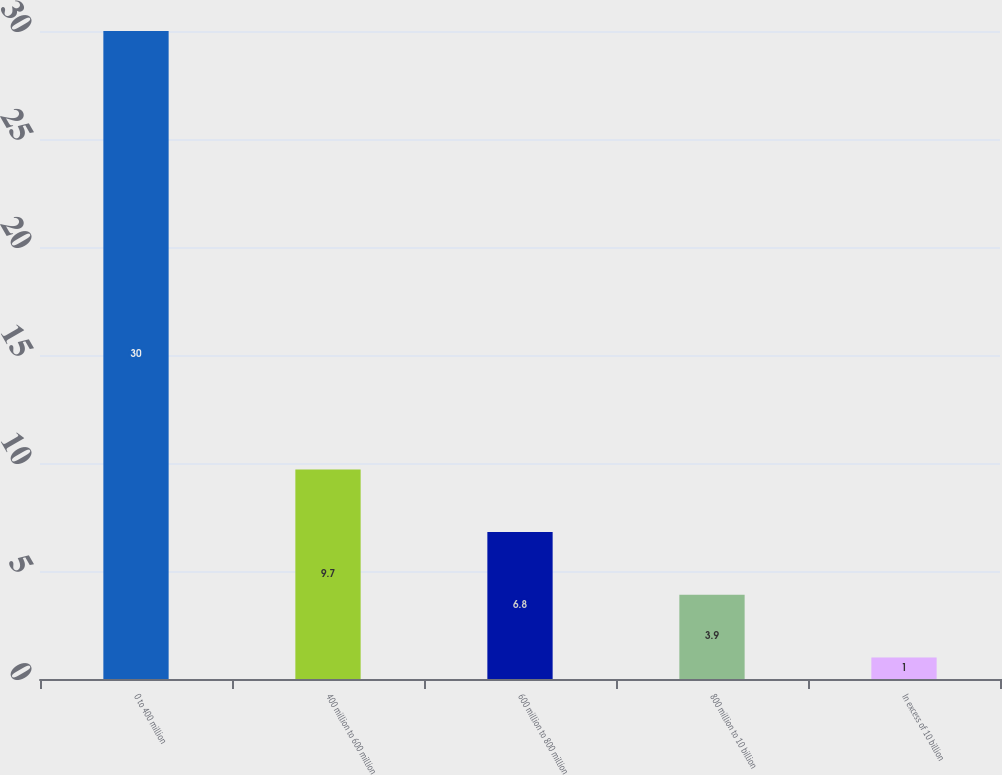<chart> <loc_0><loc_0><loc_500><loc_500><bar_chart><fcel>0 to 400 million<fcel>400 million to 600 million<fcel>600 million to 800 million<fcel>800 million to 10 billion<fcel>In excess of 10 billion<nl><fcel>30<fcel>9.7<fcel>6.8<fcel>3.9<fcel>1<nl></chart> 